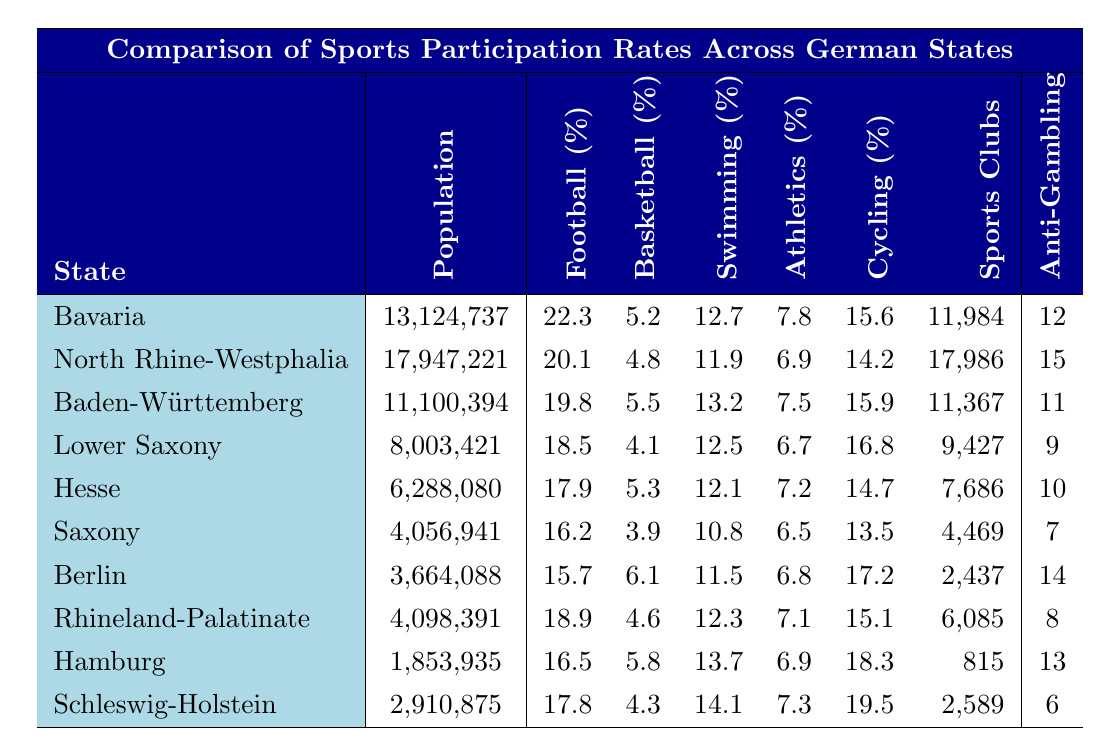What is the sports participation rate for football in Bavaria? The table shows that the football participation rate in Bavaria is listed as 22.3%.
Answer: 22.3% Which state has the highest participation rate in swimming? By examining the swimming participation rates in the table, we find that Schleswig-Holstein has the highest rate at 14.1%.
Answer: 14.1% How many sports clubs are there in North Rhine-Westphalia? The table indicates that North Rhine-Westphalia has 17,986 sports clubs.
Answer: 17,986 What is the average basketball participation rate across all the states? To calculate the average, we sum the basketball participation rates (5.2 + 4.8 + 5.5 + 4.1 + 5.3 + 3.9 + 6.1 + 4.6 + 5.8 + 4.3) = 56.6, then divide by the number of states (10), resulting in an average of 5.66%.
Answer: 5.66% Is it true that Saxony has a higher cycling participation rate than Hesse? Comparing the cycling participation rates, Saxony has 13.5% while Hesse has 14.7%, which means Saxony has a lower participation rate.
Answer: No What is the difference in football participation rate between Berlin and Lower Saxony? The football participation rate for Berlin is 15.7% and for Lower Saxony it is 18.5%. The difference is 18.5% - 15.7% = 2.8%.
Answer: 2.8% Which state has the least number of sports clubs and how many are there? From the table, we see that Hamburg has the least number of sports clubs, totaling 815.
Answer: 815 If we take the states with participation rates over 20% in football, how many states is that? In the table, only Bavaria with a rate of 22.3% meets the criterion, thus there is 1 state.
Answer: 1 What is the total population of all the states combined? Adding the populations from all the states (13,124,737 + 17,947,221 + 11,100,394 + 8,003,421 + 6,288,080 + 4,056,941 + 3,664,088 + 4,098,391 + 1,853,935 + 2,910,875) sums up to 73,028,163.
Answer: 73,028,163 Compare the number of anti-gambling campaigns between states with the highest and lowest football participation rates. Bavaria has 12 anti-gambling campaigns (highest football participation) and Schleswig-Holstein has 6 (lowest football participation). The difference is 12 - 6 = 6 campaigns.
Answer: 6 campaigns 